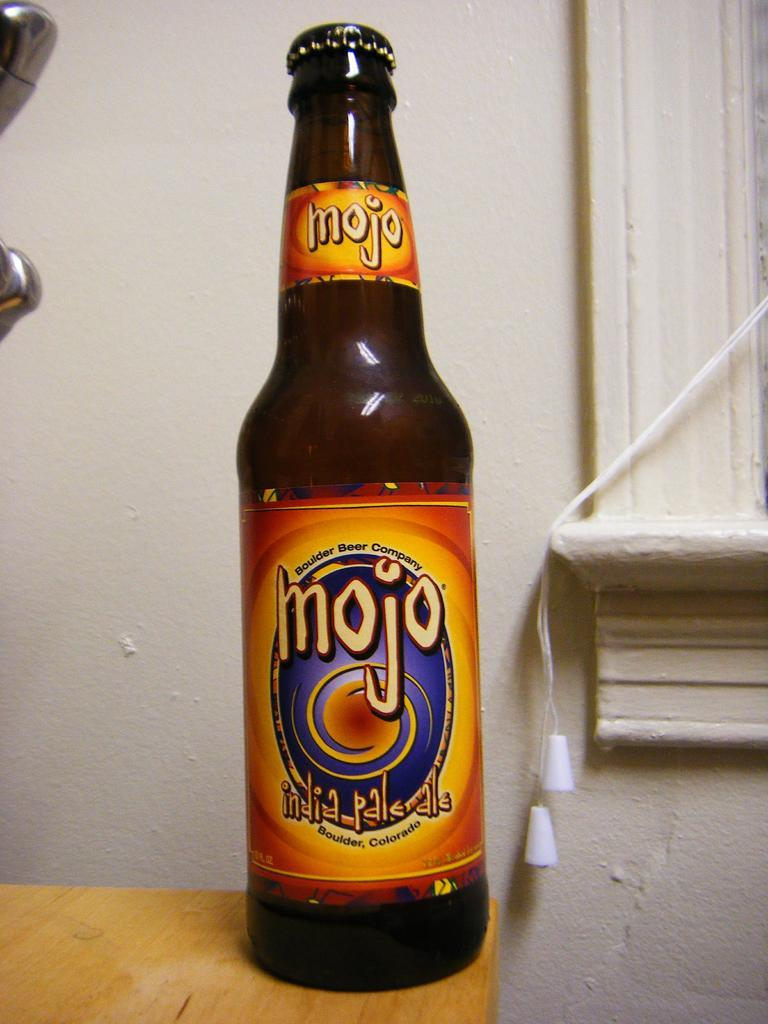Provide a one-sentence caption for the provided image. a bottle of mojo india palrdle with an orange label. 